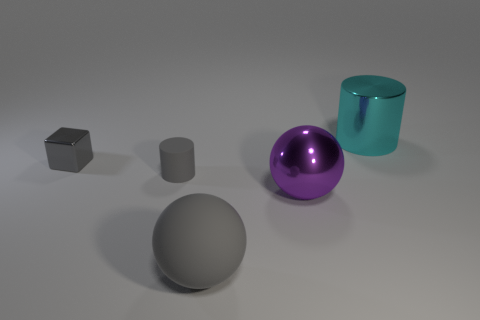Can you tell me what materials the objects seem to be made of based on their appearance? Certainly! The sphere in the foreground has a matte finish suggesting it could be made of plastic or rubber. The purple sphere has a shiny surface, hinting at a metallic or painted finish. The cylinder appears glass-like, with a translucent, reflective property. The block on the left has a textured, matte appearance, consistent with a metallic material, while the other smaller cylinder looks to be made of a rubber or matte plastic material. 